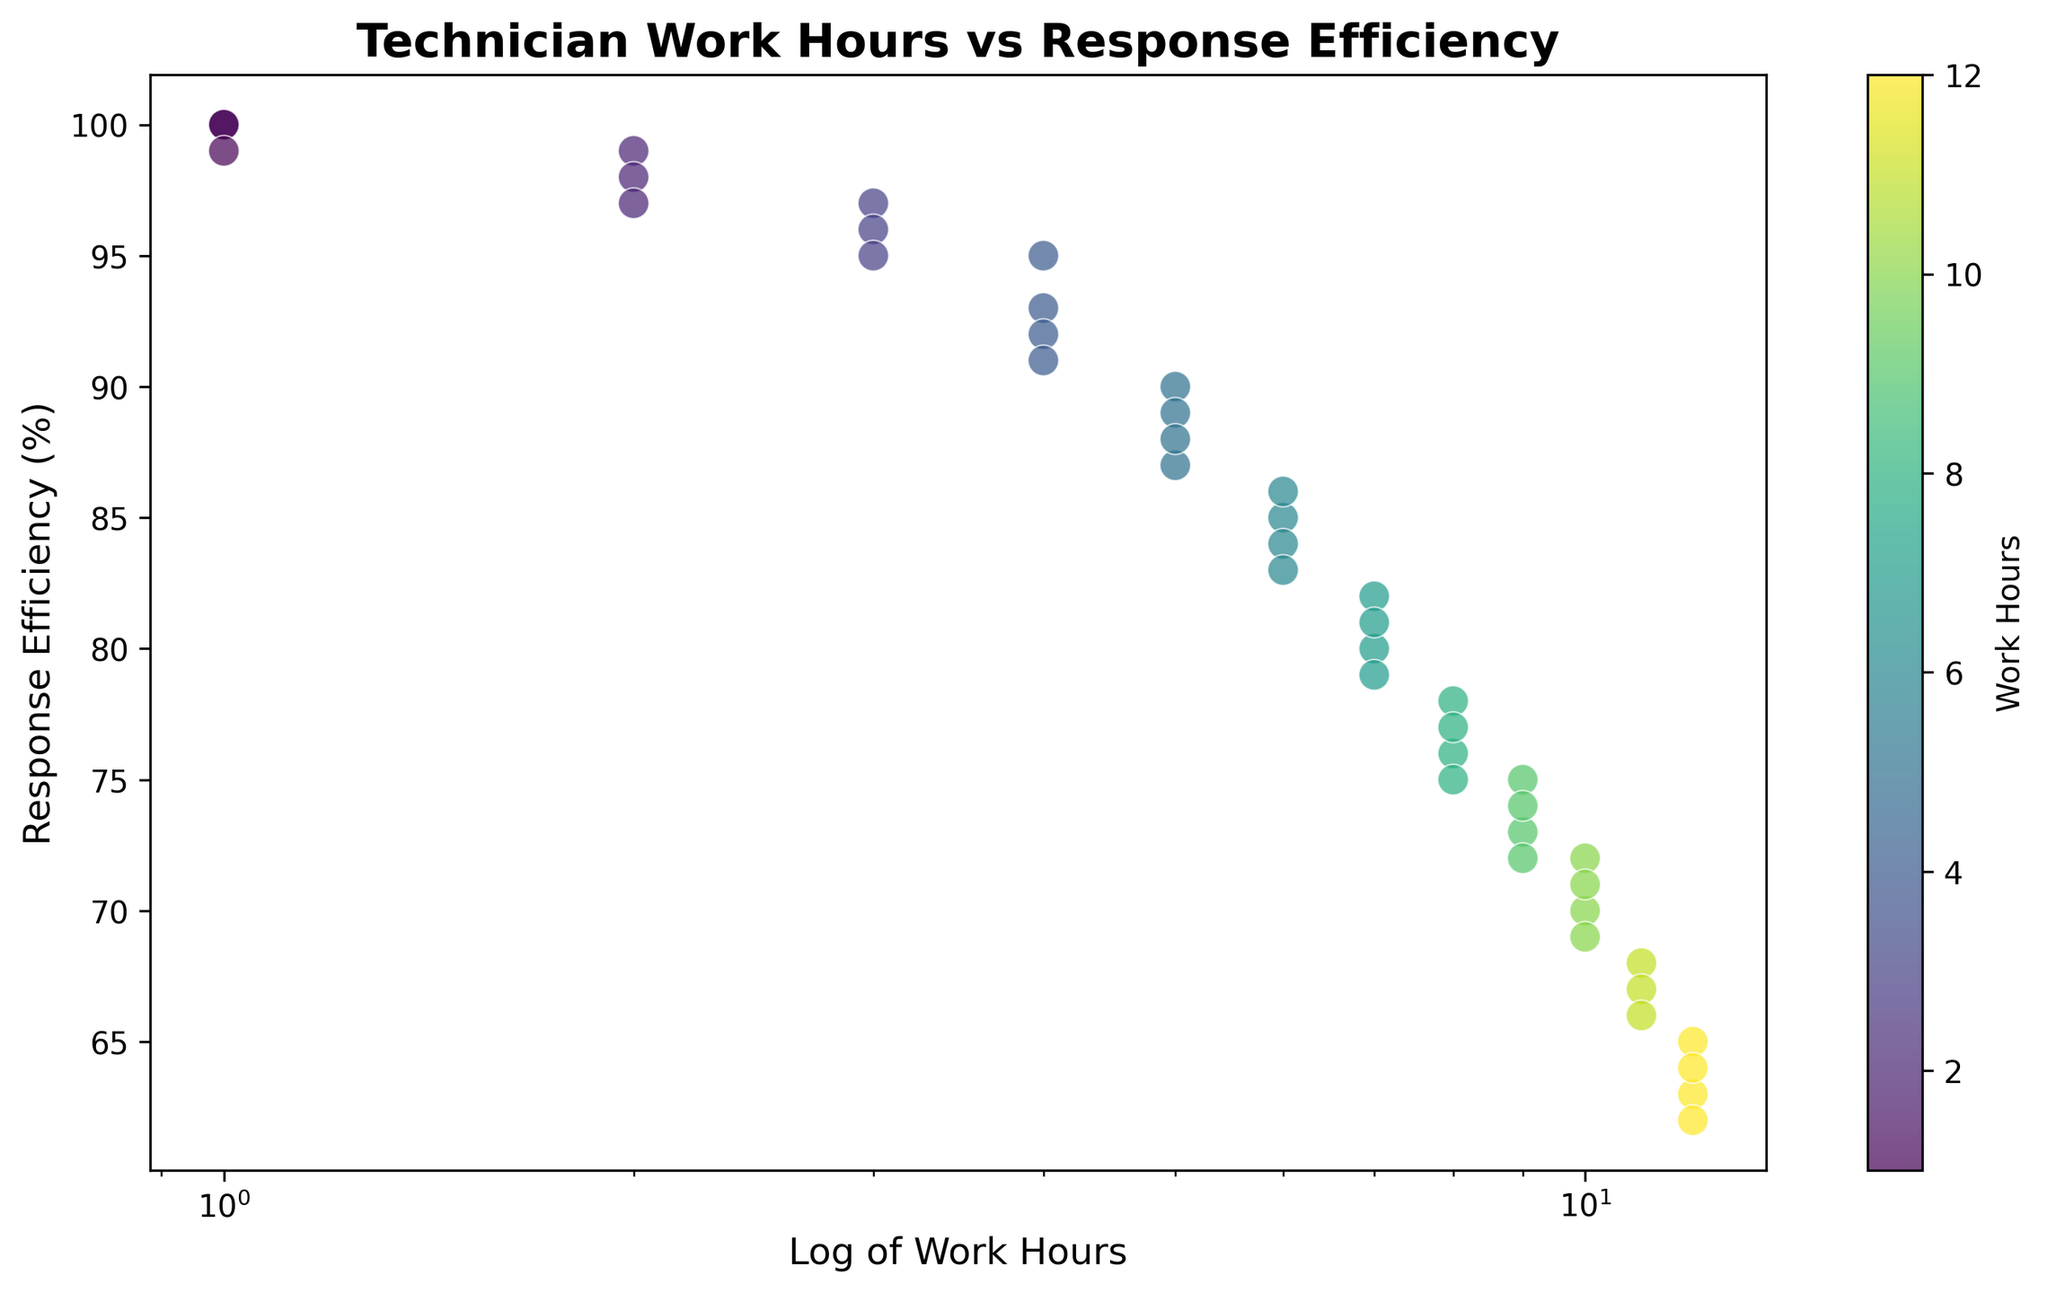Which technician has the highest response efficiency? By looking at the scatter plot, we can identify that the technician with 1 work hour has the highest response efficiency at 100%.
Answer: Technician with 1 work hour Between technicians with 10 and 11 work hours, who has better response efficiency? The scatter plot shows that a technician with 10 work hours has a response efficiency of 70%, whereas a technician with 11 work hours has a response efficiency of 68%, so the technician with 10 work hours has a slightly better response efficiency.
Answer: Technician with 10 work hours What is the color indicating work hours of 8, and how does it correlate with response efficiency? The color bar indicates that the color for work hours of 8 falls within a certain range of shades. By locating the points with work hours of 8 on the scatter plot, we see that their response efficiencies are around 77% to 75%.
Answer: Dark green to green, 75%-77% response efficiency What is the range of response efficiency for technicians with 4 work hours? By examining the points on the scatter plot for technicians with 4 work hours, we see response efficiencies between 91% and 95%.
Answer: 91% to 95% Compare the response efficiency of technicians with 1 work hour and 12 work hours. Technicians with 1 work hour have response efficiencies of 100%, whereas technicians with 12 work hours have response efficiencies around 62%-65%. Thus, technicians with 1 work hour have substantially higher response efficiencies.
Answer: 1 work hour: 100%, 12 work hours: 62%-65% How does response efficiency change as work hours increase from 1 to 12? The scatter plot, especially given the log scale on the x-axis, shows a general downward trend in response efficiency as work hours increase from 1 to 12.
Answer: Decreases Which group of work hours demonstrates the most variation in response efficiency? By examining clusters of data points, we see that technicians with work hours around 6 to 8 show a relatively wider spread in response efficiency, typically ranging from mid-70% to mid-80%.
Answer: 6 to 8 work hours Are there any technicians with equally high response efficiency at different work hours? By checking the scatter plot closely, we notice that technicians with 1 and 2 work hours both have extremely high response efficiencies of 100% and 99% respectively.
Answer: Yes, 1 and 2 work hours 